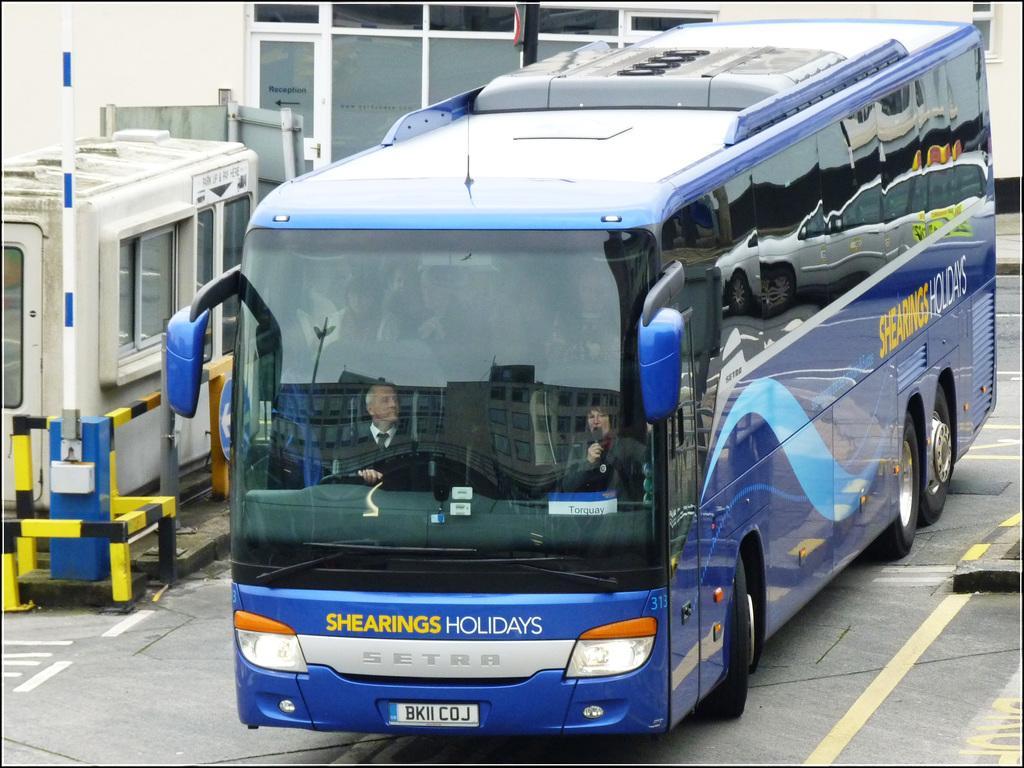Could you give a brief overview of what you see in this image? In this image in the middle there is a bus, inside that there are two men and some people. At the bottom there is road. In the background there are windows, glasses, poles, wall, sign board. 